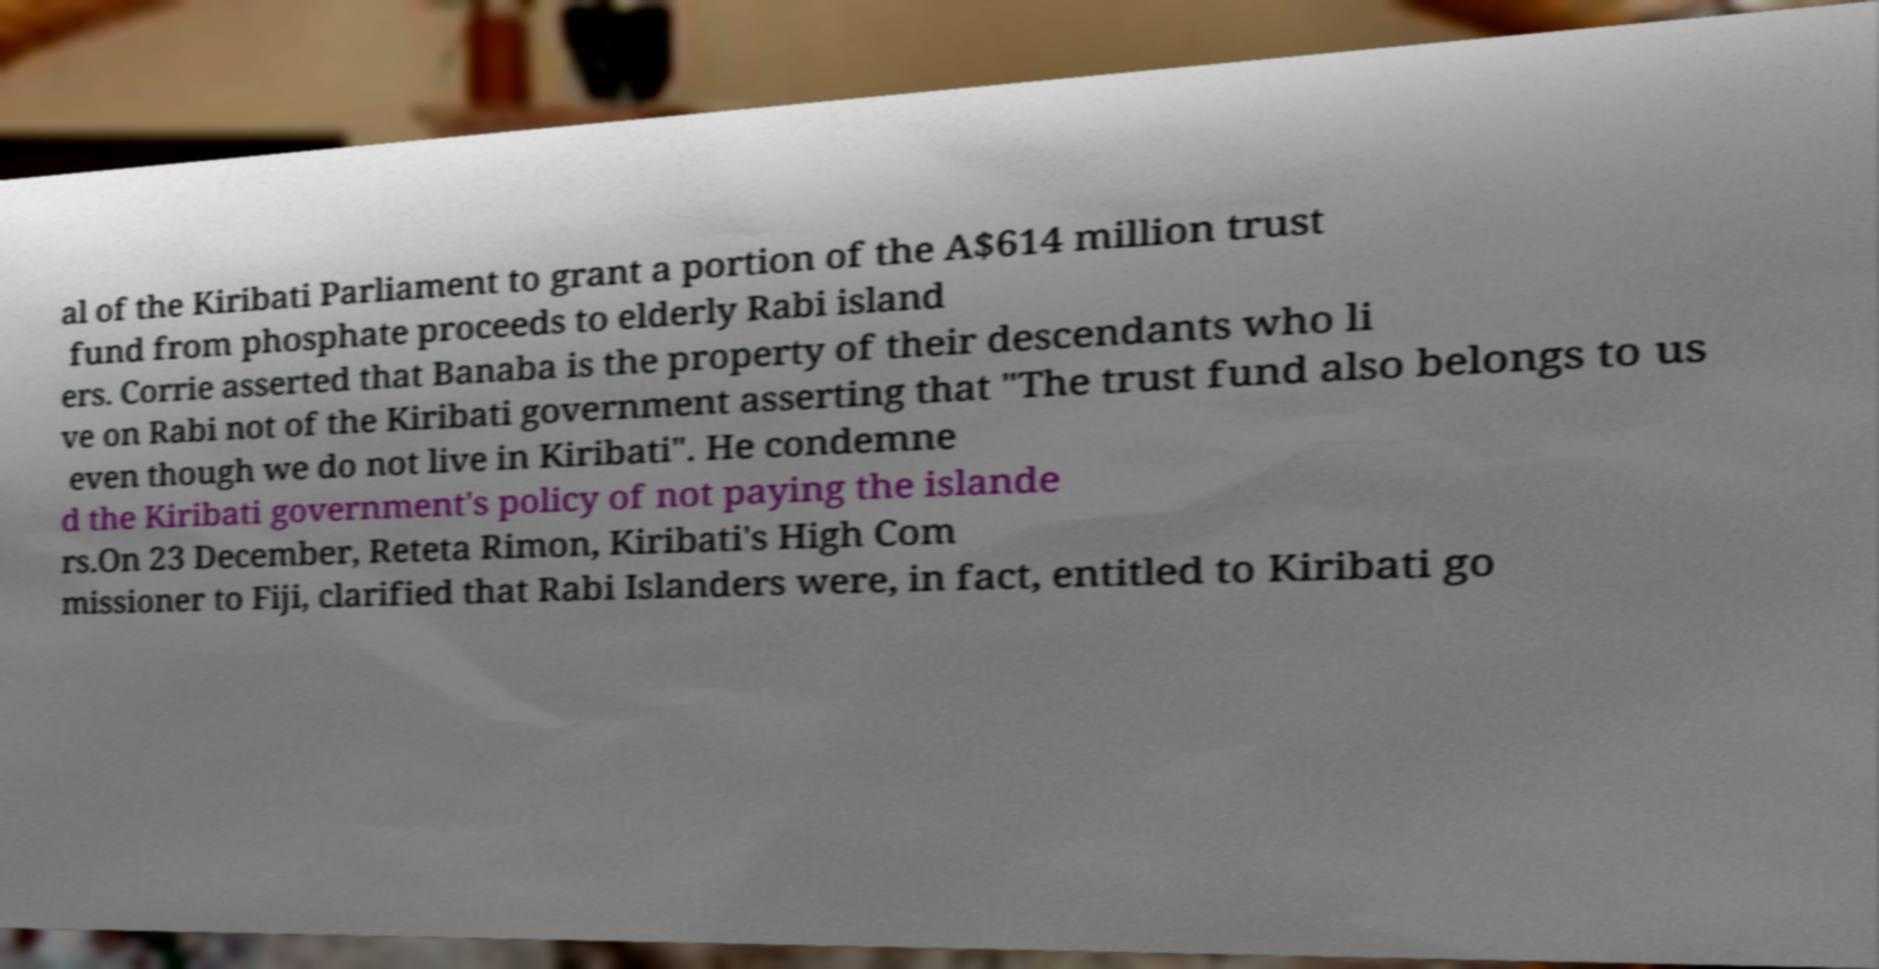Please identify and transcribe the text found in this image. al of the Kiribati Parliament to grant a portion of the A$614 million trust fund from phosphate proceeds to elderly Rabi island ers. Corrie asserted that Banaba is the property of their descendants who li ve on Rabi not of the Kiribati government asserting that "The trust fund also belongs to us even though we do not live in Kiribati". He condemne d the Kiribati government's policy of not paying the islande rs.On 23 December, Reteta Rimon, Kiribati's High Com missioner to Fiji, clarified that Rabi Islanders were, in fact, entitled to Kiribati go 